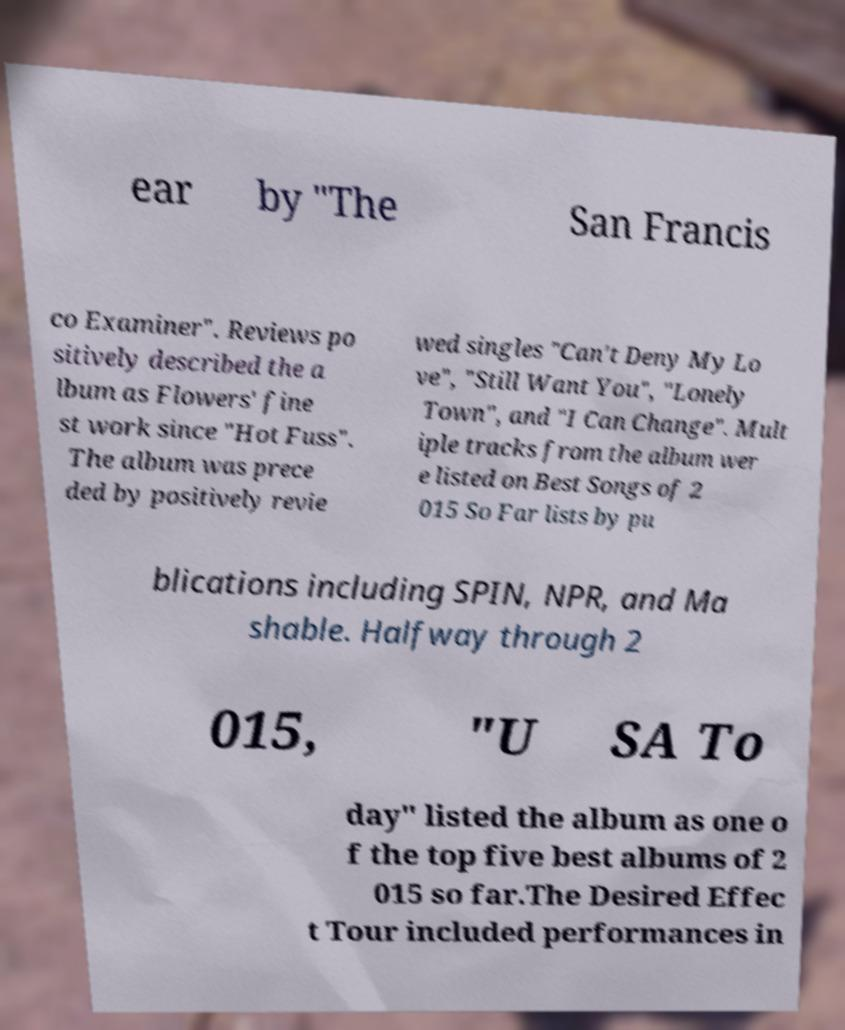Can you accurately transcribe the text from the provided image for me? ear by "The San Francis co Examiner". Reviews po sitively described the a lbum as Flowers' fine st work since "Hot Fuss". The album was prece ded by positively revie wed singles "Can't Deny My Lo ve", "Still Want You", "Lonely Town", and "I Can Change". Mult iple tracks from the album wer e listed on Best Songs of 2 015 So Far lists by pu blications including SPIN, NPR, and Ma shable. Halfway through 2 015, "U SA To day" listed the album as one o f the top five best albums of 2 015 so far.The Desired Effec t Tour included performances in 